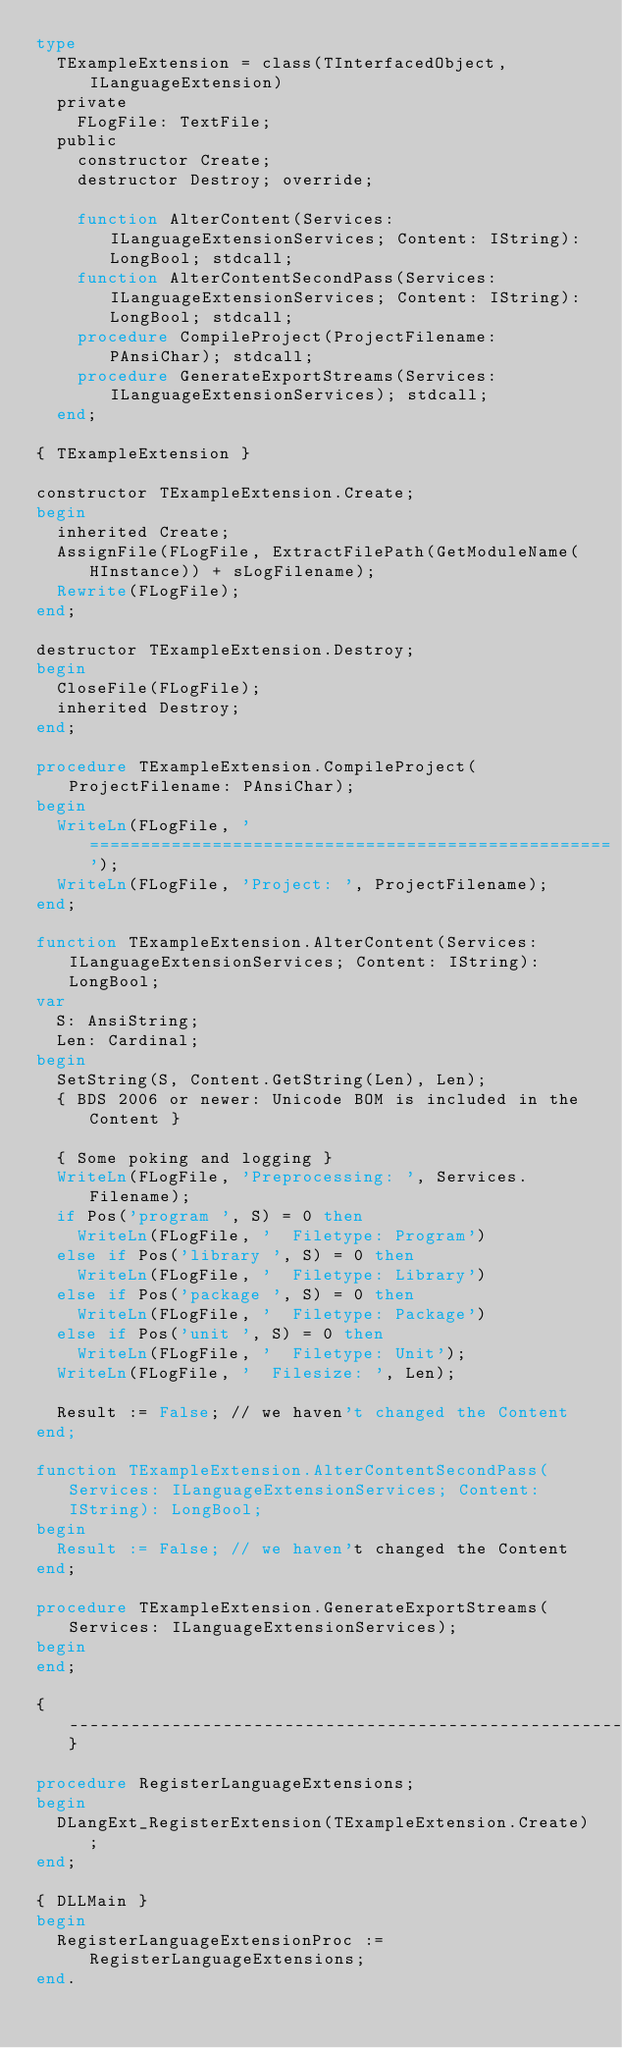Convert code to text. <code><loc_0><loc_0><loc_500><loc_500><_Pascal_>type
  TExampleExtension = class(TInterfacedObject, ILanguageExtension)
  private
    FLogFile: TextFile;
  public
    constructor Create;
    destructor Destroy; override;

    function AlterContent(Services: ILanguageExtensionServices; Content: IString): LongBool; stdcall;
    function AlterContentSecondPass(Services: ILanguageExtensionServices; Content: IString): LongBool; stdcall;
    procedure CompileProject(ProjectFilename: PAnsiChar); stdcall;
    procedure GenerateExportStreams(Services: ILanguageExtensionServices); stdcall;
  end;

{ TExampleExtension }

constructor TExampleExtension.Create;
begin
  inherited Create;
  AssignFile(FLogFile, ExtractFilePath(GetModuleName(HInstance)) + sLogFilename);
  Rewrite(FLogFile);
end;

destructor TExampleExtension.Destroy;
begin
  CloseFile(FLogFile);
  inherited Destroy;
end;

procedure TExampleExtension.CompileProject(ProjectFilename: PAnsiChar);
begin
  WriteLn(FLogFile, '===================================================');
  WriteLn(FLogFile, 'Project: ', ProjectFilename);
end;

function TExampleExtension.AlterContent(Services: ILanguageExtensionServices; Content: IString): LongBool;
var
  S: AnsiString;
  Len: Cardinal;
begin
  SetString(S, Content.GetString(Len), Len);
  { BDS 2006 or newer: Unicode BOM is included in the Content }

  { Some poking and logging }
  WriteLn(FLogFile, 'Preprocessing: ', Services.Filename);
  if Pos('program ', S) = 0 then
    WriteLn(FLogFile, '  Filetype: Program')
  else if Pos('library ', S) = 0 then
    WriteLn(FLogFile, '  Filetype: Library')
  else if Pos('package ', S) = 0 then
    WriteLn(FLogFile, '  Filetype: Package')
  else if Pos('unit ', S) = 0 then
    WriteLn(FLogFile, '  Filetype: Unit');
  WriteLn(FLogFile, '  Filesize: ', Len);

  Result := False; // we haven't changed the Content
end;

function TExampleExtension.AlterContentSecondPass(Services: ILanguageExtensionServices; Content: IString): LongBool;
begin
  Result := False; // we haven't changed the Content
end;

procedure TExampleExtension.GenerateExportStreams(Services: ILanguageExtensionServices);
begin
end;

{--------------------------------------------------------------------------------------------------}

procedure RegisterLanguageExtensions;
begin
  DLangExt_RegisterExtension(TExampleExtension.Create);
end;

{ DLLMain }
begin
  RegisterLanguageExtensionProc := RegisterLanguageExtensions;
end.
</code> 